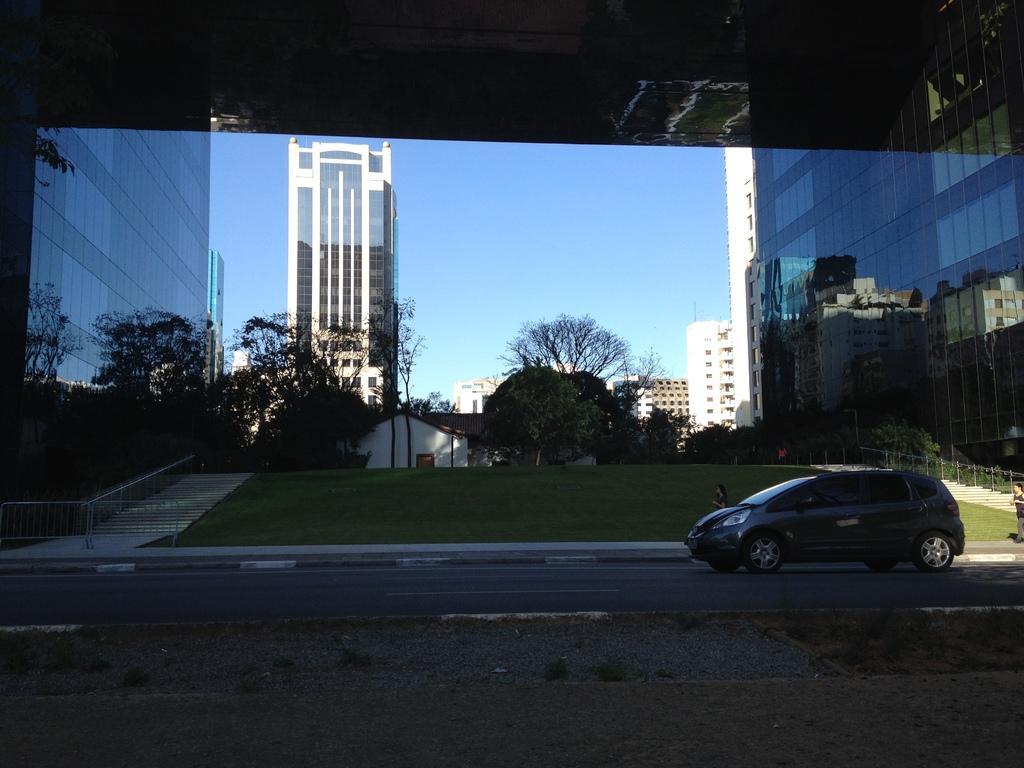Please provide a concise description of this image. In this image I can see a car and a person on the road. In the background I can see grass, fence, steps, buildings, trees, houses, poles, glass and the sky. This image is taken may be on the road. 